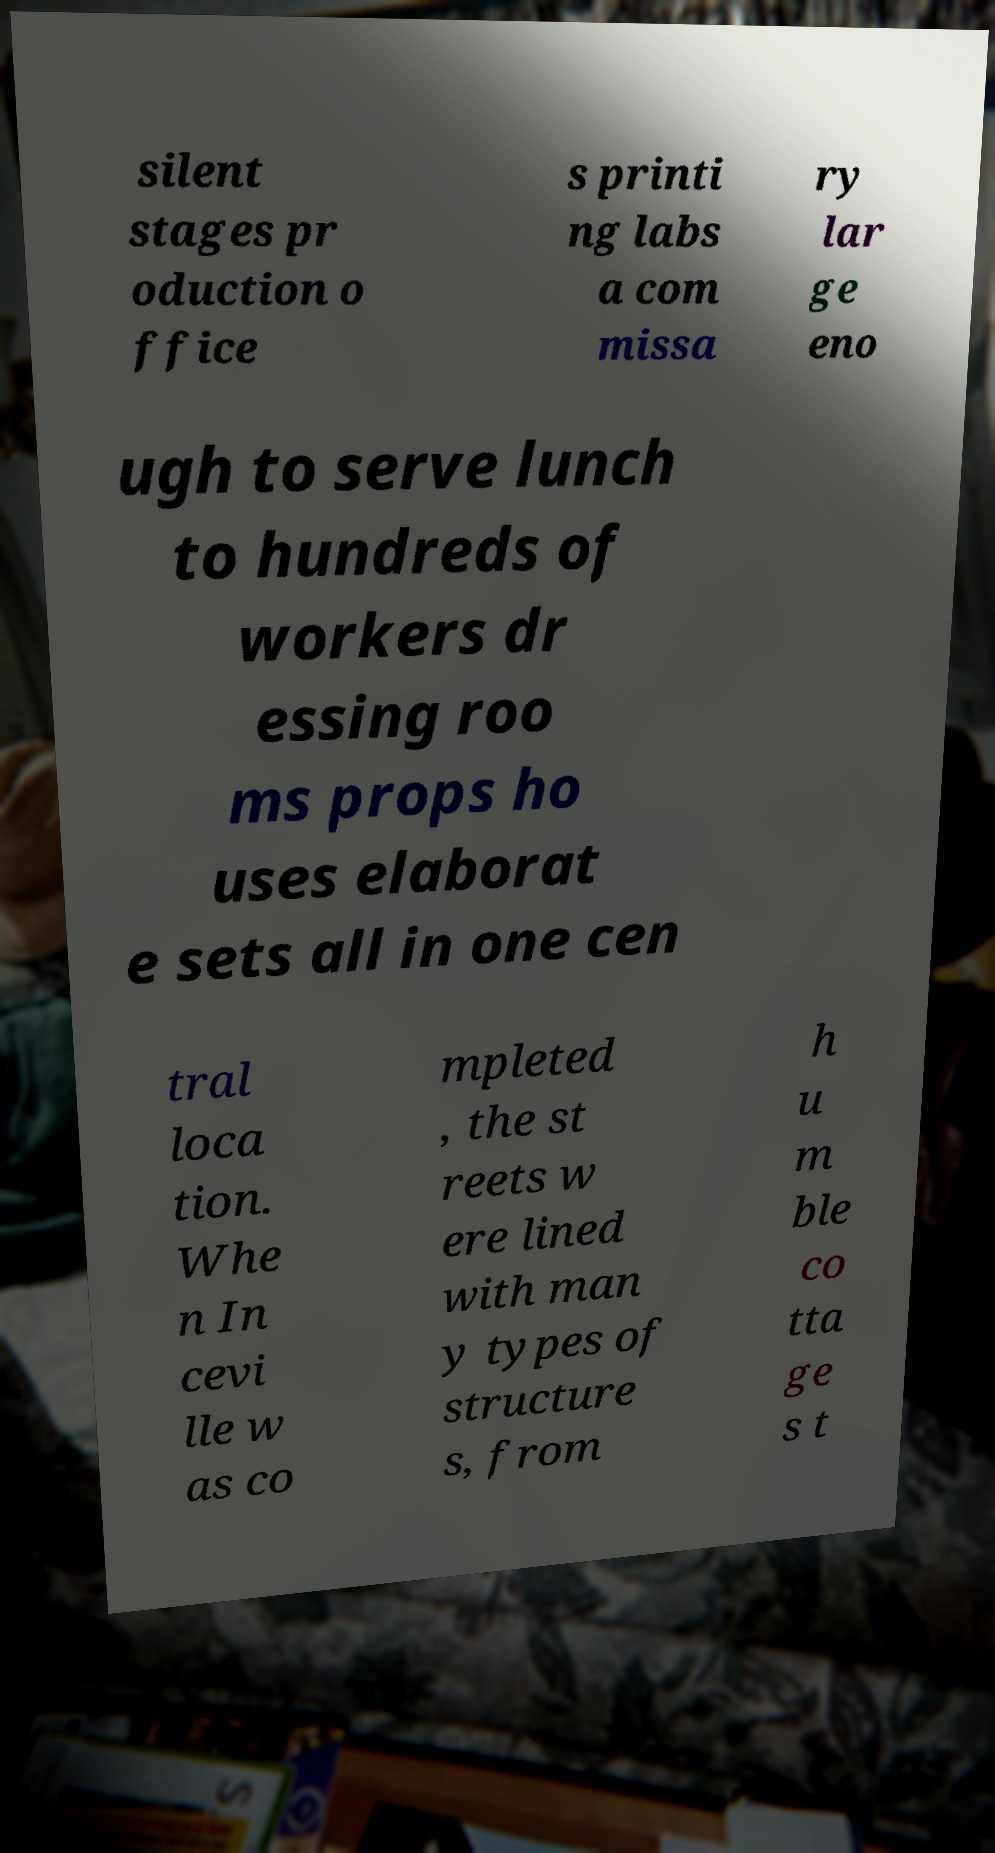Can you read and provide the text displayed in the image?This photo seems to have some interesting text. Can you extract and type it out for me? silent stages pr oduction o ffice s printi ng labs a com missa ry lar ge eno ugh to serve lunch to hundreds of workers dr essing roo ms props ho uses elaborat e sets all in one cen tral loca tion. Whe n In cevi lle w as co mpleted , the st reets w ere lined with man y types of structure s, from h u m ble co tta ge s t 